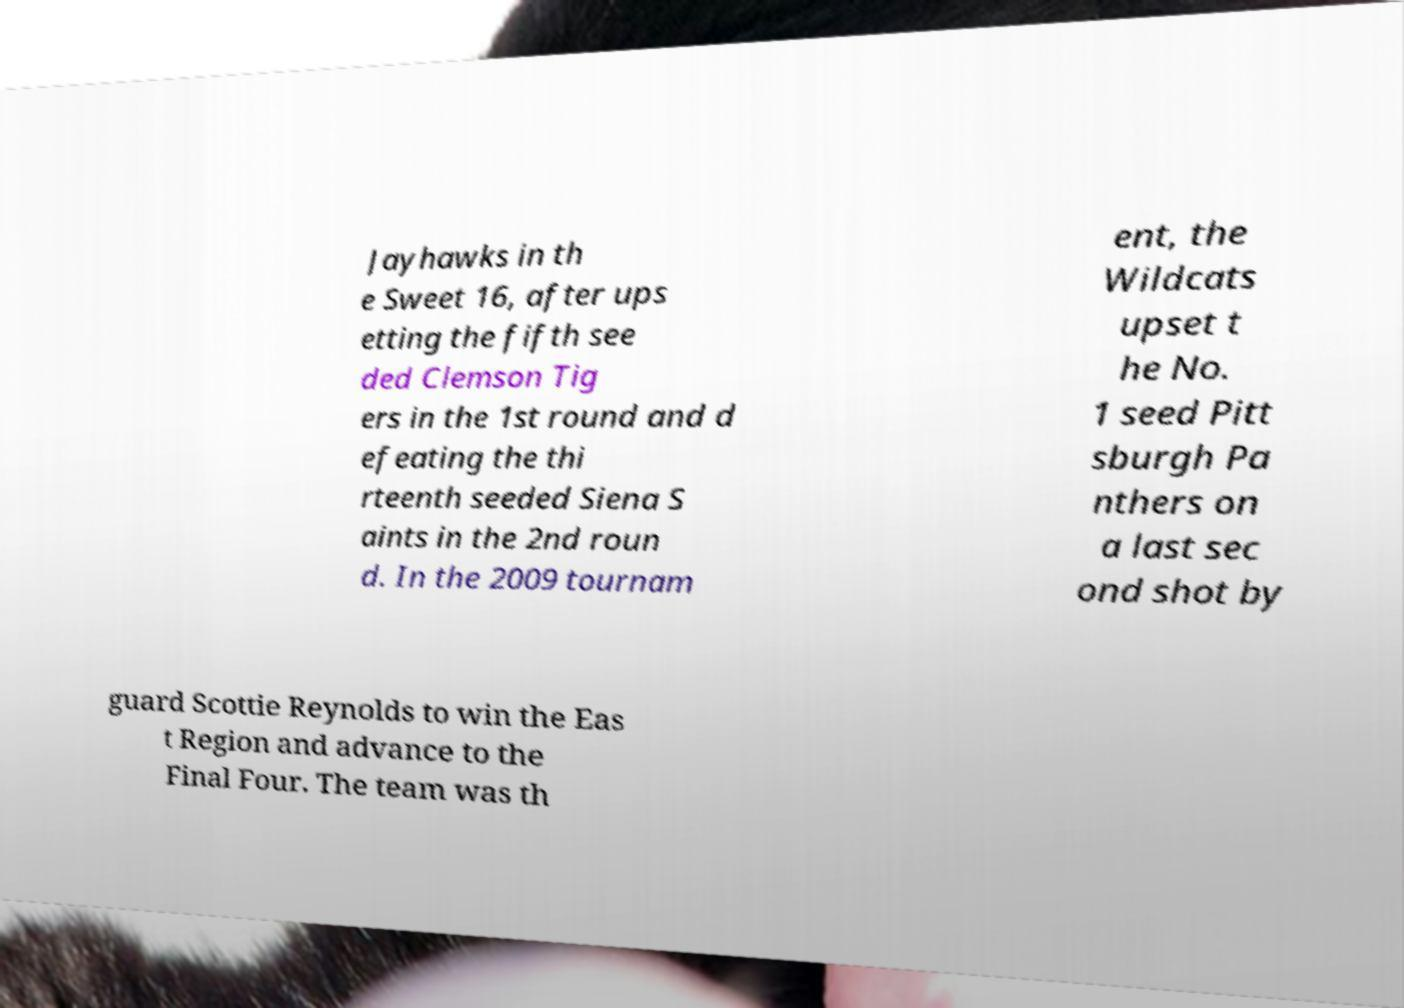Can you accurately transcribe the text from the provided image for me? Jayhawks in th e Sweet 16, after ups etting the fifth see ded Clemson Tig ers in the 1st round and d efeating the thi rteenth seeded Siena S aints in the 2nd roun d. In the 2009 tournam ent, the Wildcats upset t he No. 1 seed Pitt sburgh Pa nthers on a last sec ond shot by guard Scottie Reynolds to win the Eas t Region and advance to the Final Four. The team was th 